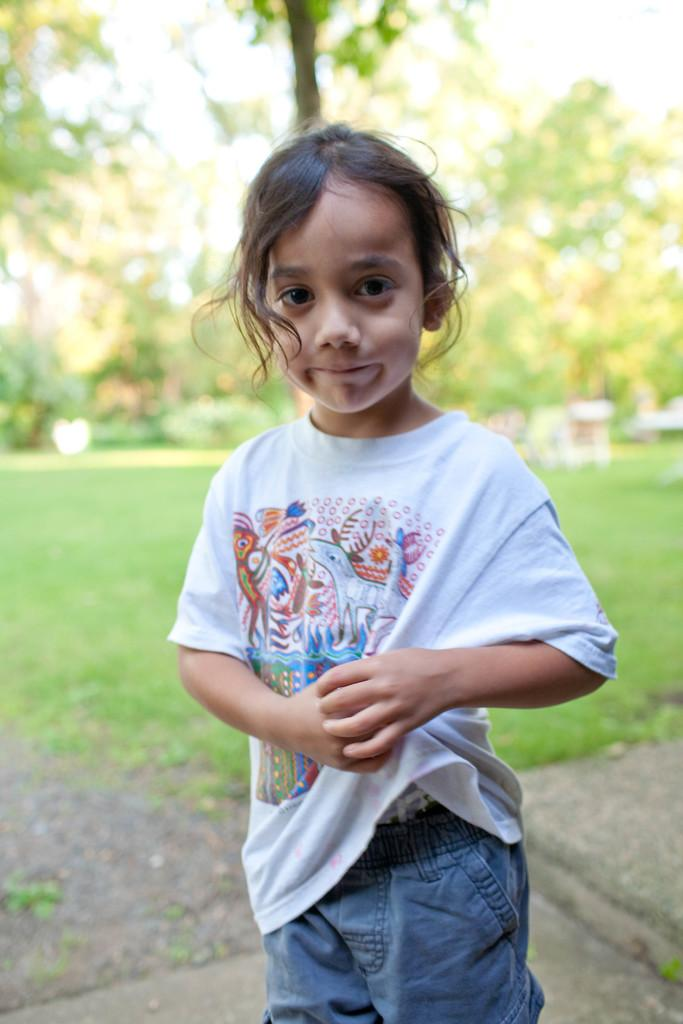Who is the main subject in the image? There is a girl standing in the middle of the image. What can be seen in the background of the image? There are trees in the background of the image. What type of vegetation is present at the bottom of the image? Grass is present at the bottom of the image. What type of land is visible in the image? There is a land visible in the image. What type of cake is the girl holding in the image? There is no cake present in the image; the girl is not holding anything. 